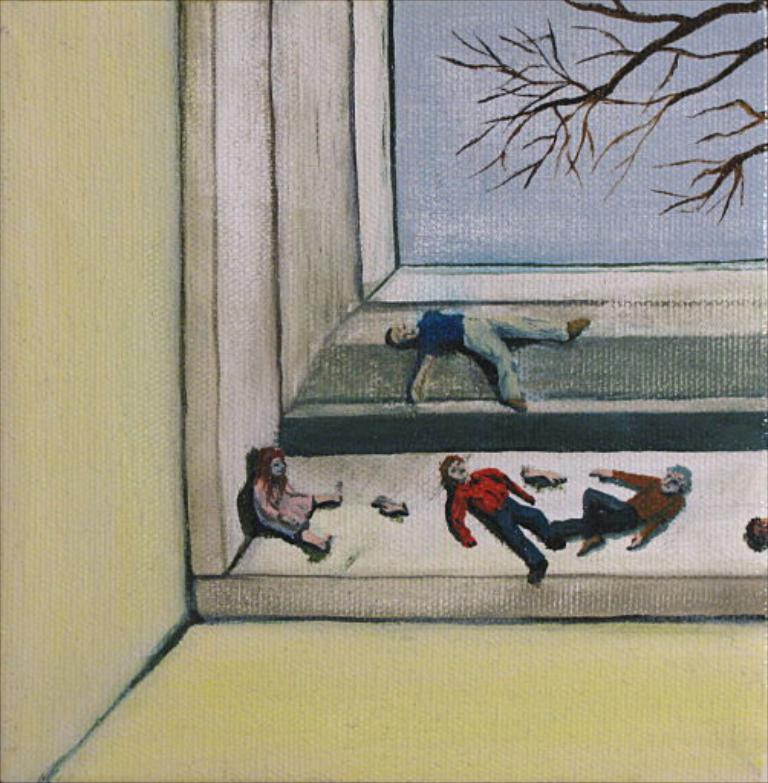What is the main subject of the image? There is a painting in the image. What are the people in the image doing? The people are lying on the floor in the image. Can you describe the background of the image? There is a tree visible in the top right corner of the image. Where is the person sitting in the image? There is a person sitting on the left side of the image. What is the name of the person sitting on the left side of the image? The provided facts do not mention the name of the person sitting on the left side of the image. 